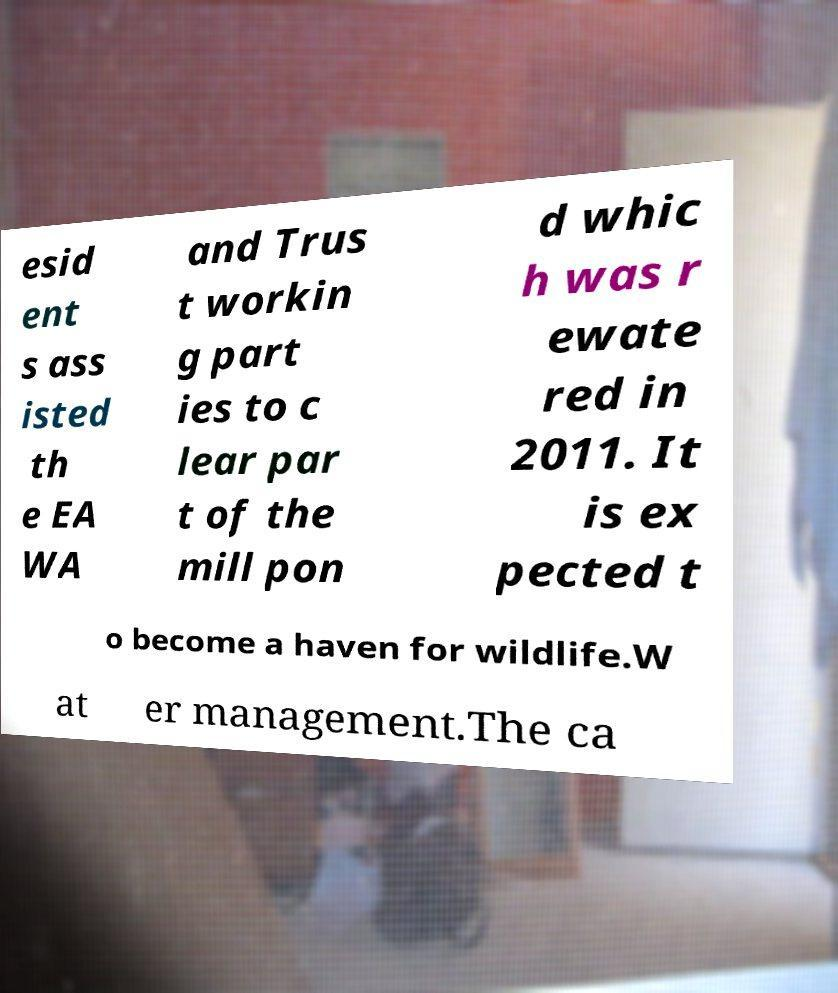Please read and relay the text visible in this image. What does it say? esid ent s ass isted th e EA WA and Trus t workin g part ies to c lear par t of the mill pon d whic h was r ewate red in 2011. It is ex pected t o become a haven for wildlife.W at er management.The ca 